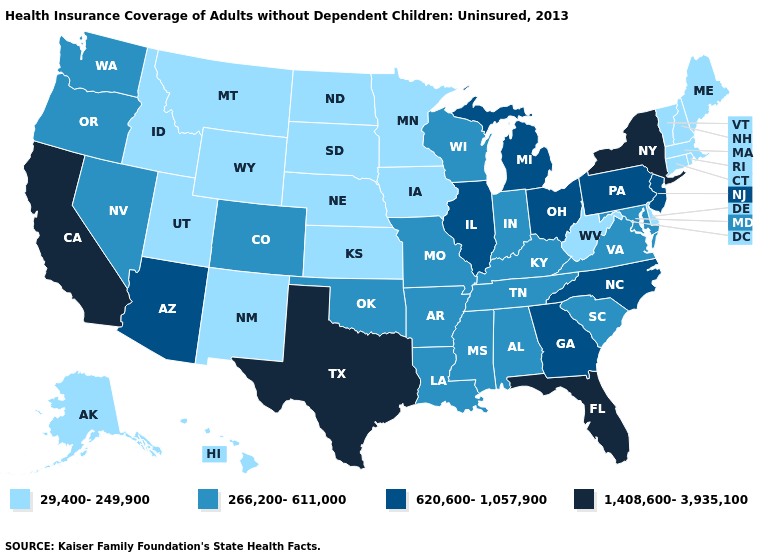Does Idaho have the highest value in the West?
Answer briefly. No. What is the value of Iowa?
Be succinct. 29,400-249,900. What is the value of Wisconsin?
Answer briefly. 266,200-611,000. Name the states that have a value in the range 266,200-611,000?
Concise answer only. Alabama, Arkansas, Colorado, Indiana, Kentucky, Louisiana, Maryland, Mississippi, Missouri, Nevada, Oklahoma, Oregon, South Carolina, Tennessee, Virginia, Washington, Wisconsin. Among the states that border South Carolina , which have the lowest value?
Quick response, please. Georgia, North Carolina. What is the highest value in the Northeast ?
Quick response, please. 1,408,600-3,935,100. Name the states that have a value in the range 620,600-1,057,900?
Concise answer only. Arizona, Georgia, Illinois, Michigan, New Jersey, North Carolina, Ohio, Pennsylvania. What is the value of Tennessee?
Concise answer only. 266,200-611,000. Does North Dakota have the lowest value in the USA?
Short answer required. Yes. Among the states that border Florida , which have the highest value?
Concise answer only. Georgia. Name the states that have a value in the range 29,400-249,900?
Answer briefly. Alaska, Connecticut, Delaware, Hawaii, Idaho, Iowa, Kansas, Maine, Massachusetts, Minnesota, Montana, Nebraska, New Hampshire, New Mexico, North Dakota, Rhode Island, South Dakota, Utah, Vermont, West Virginia, Wyoming. Does Virginia have the same value as Pennsylvania?
Write a very short answer. No. Among the states that border Arizona , does Utah have the lowest value?
Be succinct. Yes. Does Oklahoma have the highest value in the USA?
Concise answer only. No. Which states have the highest value in the USA?
Short answer required. California, Florida, New York, Texas. 